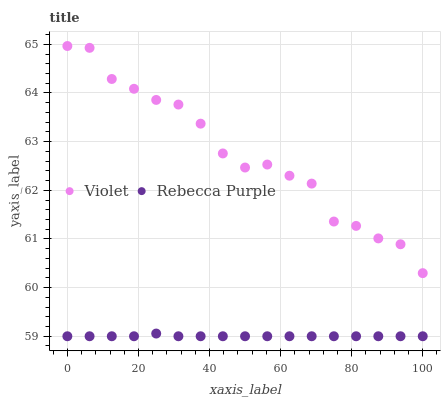Does Rebecca Purple have the minimum area under the curve?
Answer yes or no. Yes. Does Violet have the maximum area under the curve?
Answer yes or no. Yes. Does Violet have the minimum area under the curve?
Answer yes or no. No. Is Rebecca Purple the smoothest?
Answer yes or no. Yes. Is Violet the roughest?
Answer yes or no. Yes. Is Violet the smoothest?
Answer yes or no. No. Does Rebecca Purple have the lowest value?
Answer yes or no. Yes. Does Violet have the lowest value?
Answer yes or no. No. Does Violet have the highest value?
Answer yes or no. Yes. Is Rebecca Purple less than Violet?
Answer yes or no. Yes. Is Violet greater than Rebecca Purple?
Answer yes or no. Yes. Does Rebecca Purple intersect Violet?
Answer yes or no. No. 